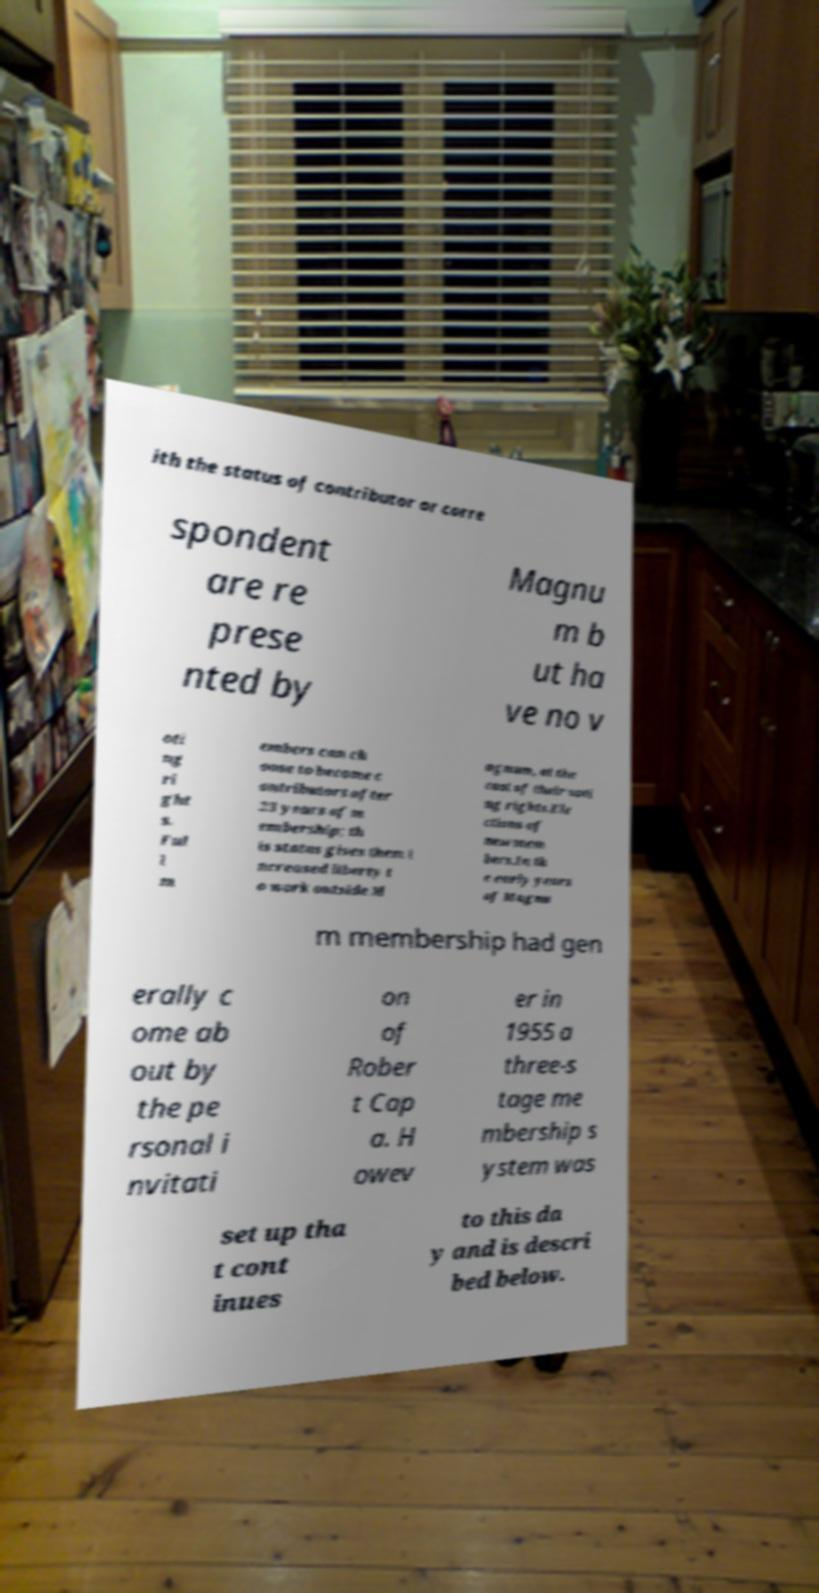Could you extract and type out the text from this image? ith the status of contributor or corre spondent are re prese nted by Magnu m b ut ha ve no v oti ng ri ght s. Ful l m embers can ch oose to become c ontributors after 23 years of m embership; th is status gives them i ncreased liberty t o work outside M agnum, at the cost of their voti ng rights.Ele ctions of new mem bers.In th e early years of Magnu m membership had gen erally c ome ab out by the pe rsonal i nvitati on of Rober t Cap a. H owev er in 1955 a three-s tage me mbership s ystem was set up tha t cont inues to this da y and is descri bed below. 